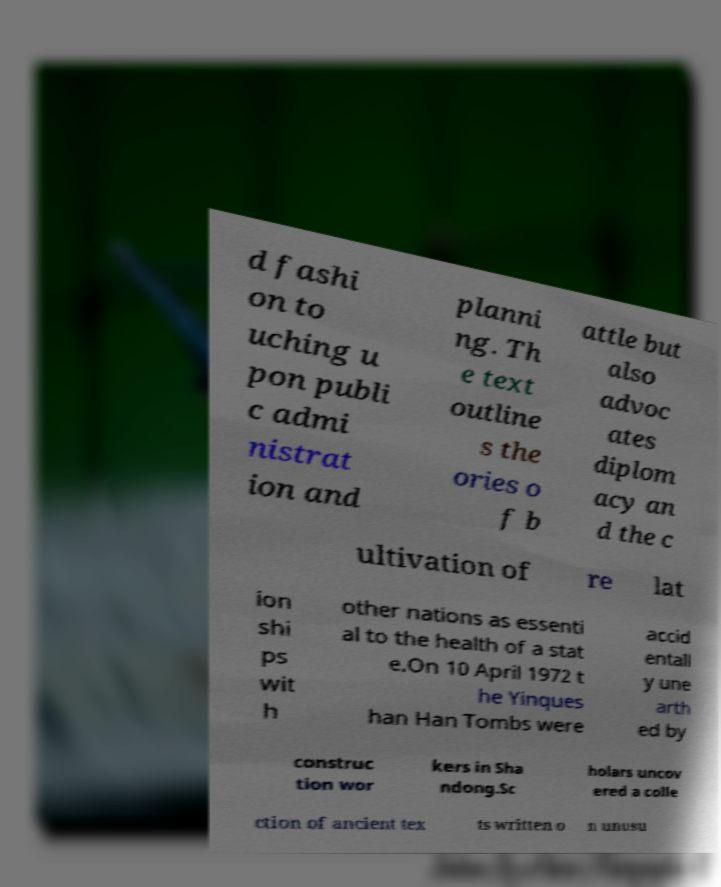Can you accurately transcribe the text from the provided image for me? d fashi on to uching u pon publi c admi nistrat ion and planni ng. Th e text outline s the ories o f b attle but also advoc ates diplom acy an d the c ultivation of re lat ion shi ps wit h other nations as essenti al to the health of a stat e.On 10 April 1972 t he Yinques han Han Tombs were accid entall y une arth ed by construc tion wor kers in Sha ndong.Sc holars uncov ered a colle ction of ancient tex ts written o n unusu 